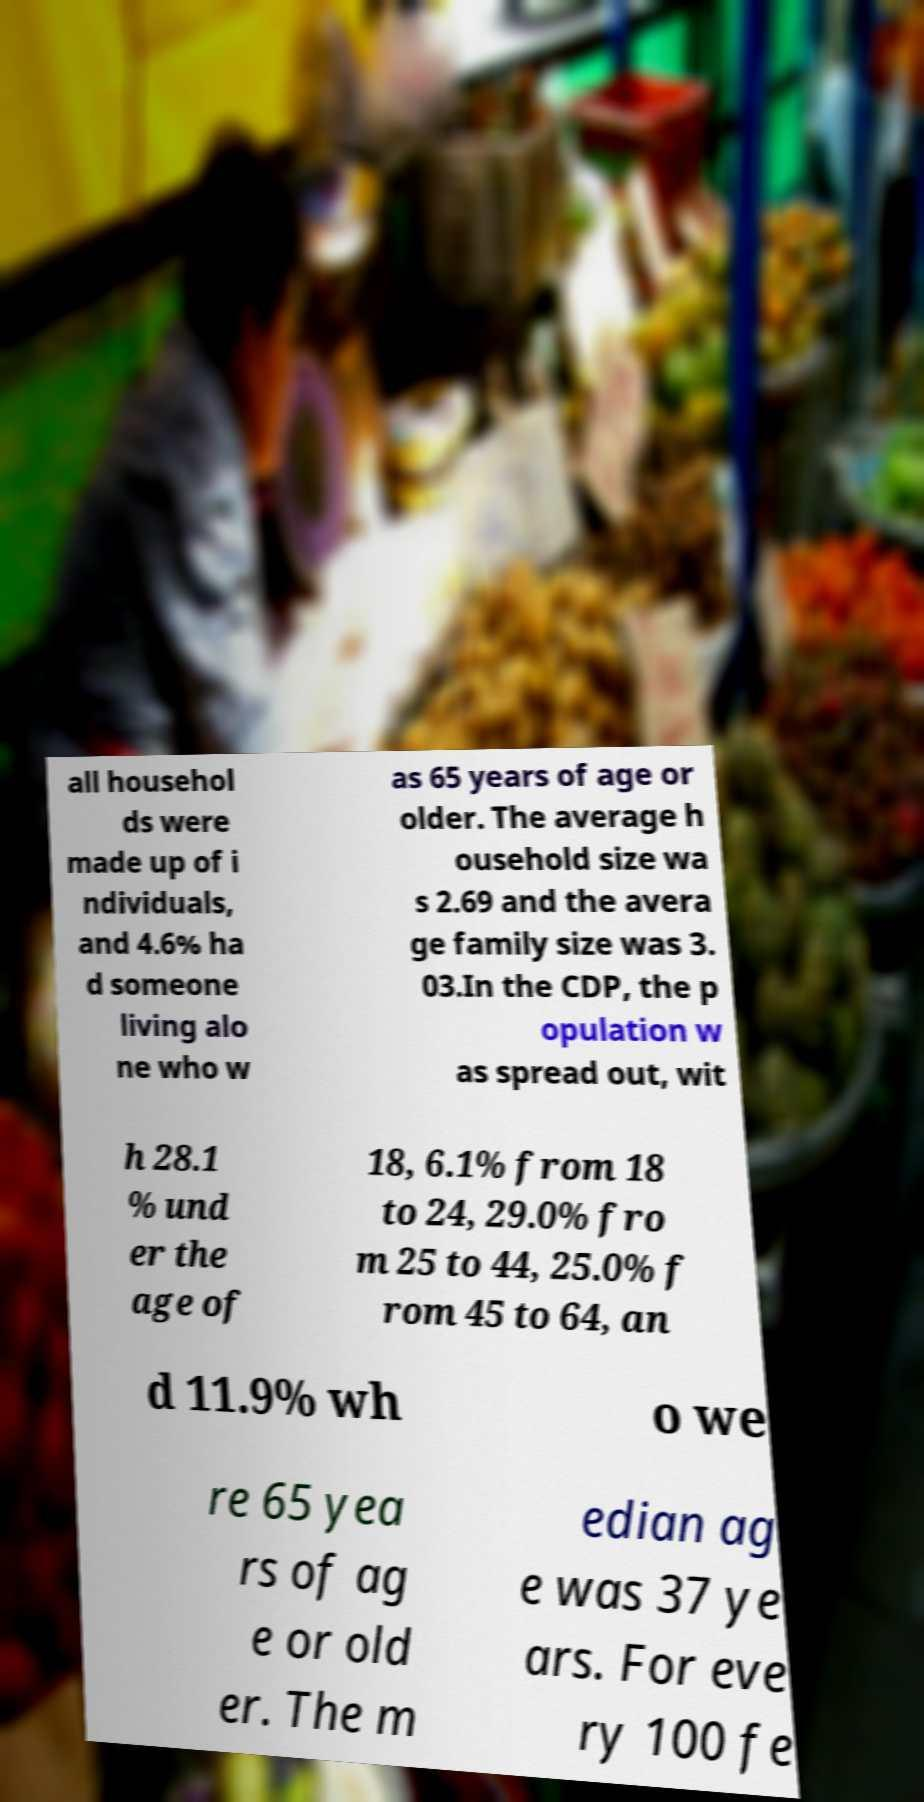I need the written content from this picture converted into text. Can you do that? all househol ds were made up of i ndividuals, and 4.6% ha d someone living alo ne who w as 65 years of age or older. The average h ousehold size wa s 2.69 and the avera ge family size was 3. 03.In the CDP, the p opulation w as spread out, wit h 28.1 % und er the age of 18, 6.1% from 18 to 24, 29.0% fro m 25 to 44, 25.0% f rom 45 to 64, an d 11.9% wh o we re 65 yea rs of ag e or old er. The m edian ag e was 37 ye ars. For eve ry 100 fe 